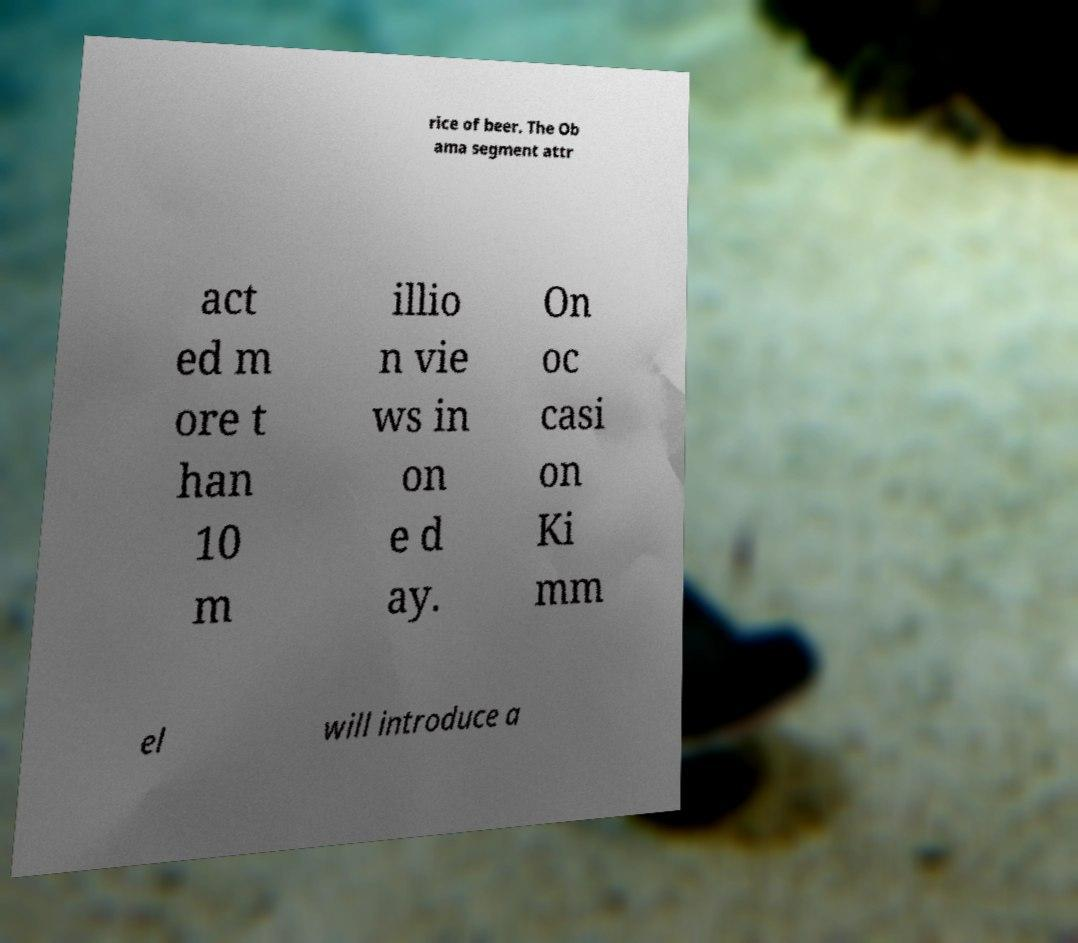Could you assist in decoding the text presented in this image and type it out clearly? rice of beer. The Ob ama segment attr act ed m ore t han 10 m illio n vie ws in on e d ay. On oc casi on Ki mm el will introduce a 